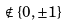<formula> <loc_0><loc_0><loc_500><loc_500>\notin \{ 0 , \pm 1 \}</formula> 